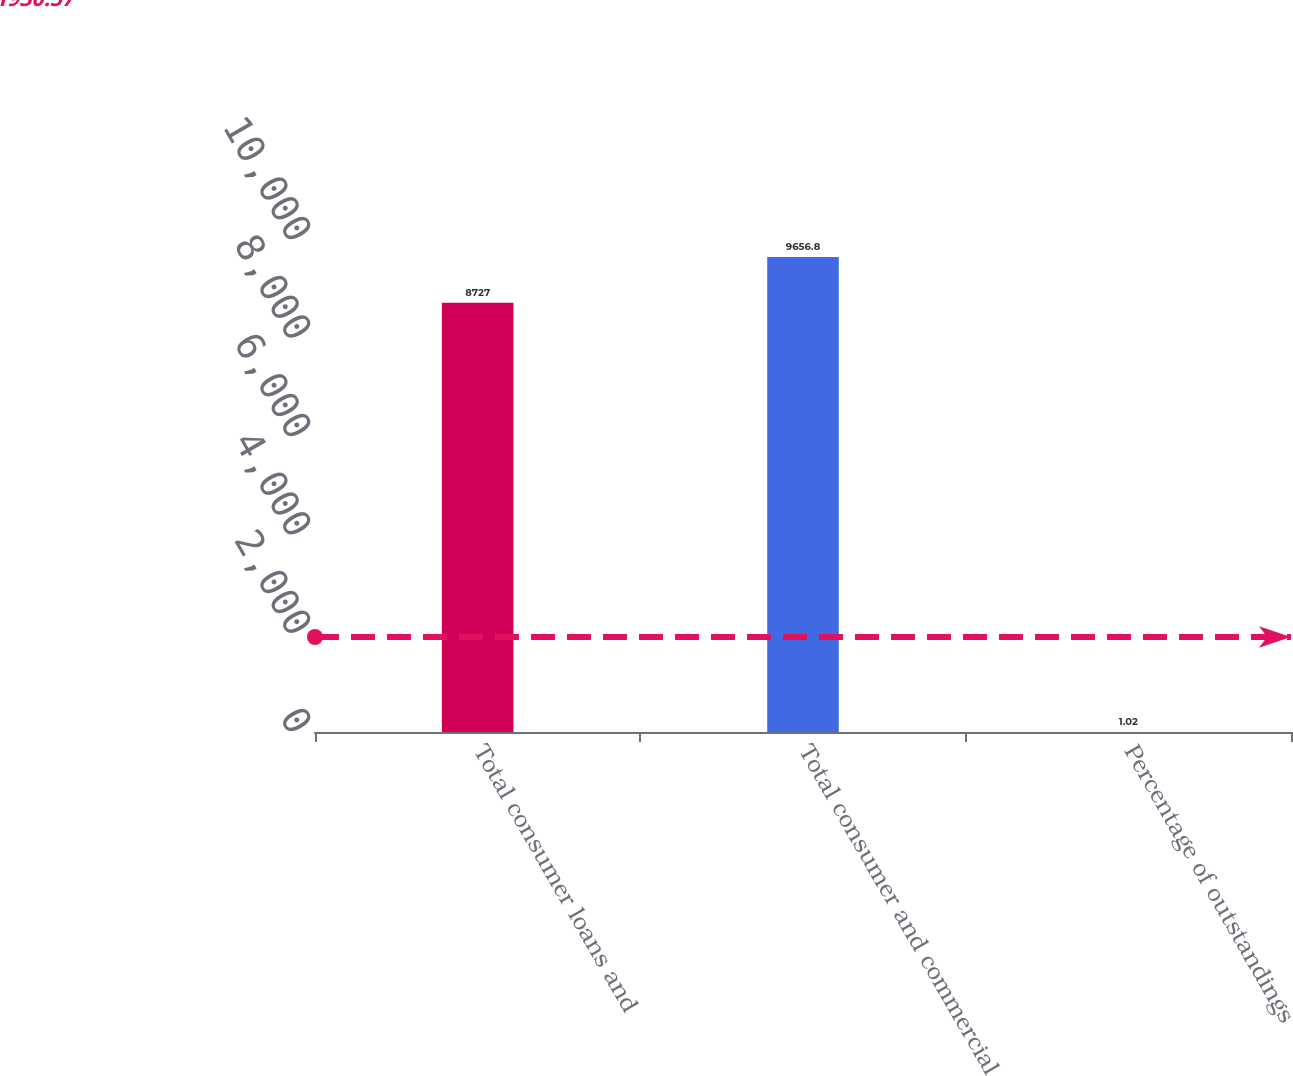Convert chart to OTSL. <chart><loc_0><loc_0><loc_500><loc_500><bar_chart><fcel>Total consumer loans and<fcel>Total consumer and commercial<fcel>Percentage of outstandings<nl><fcel>8727<fcel>9656.8<fcel>1.02<nl></chart> 